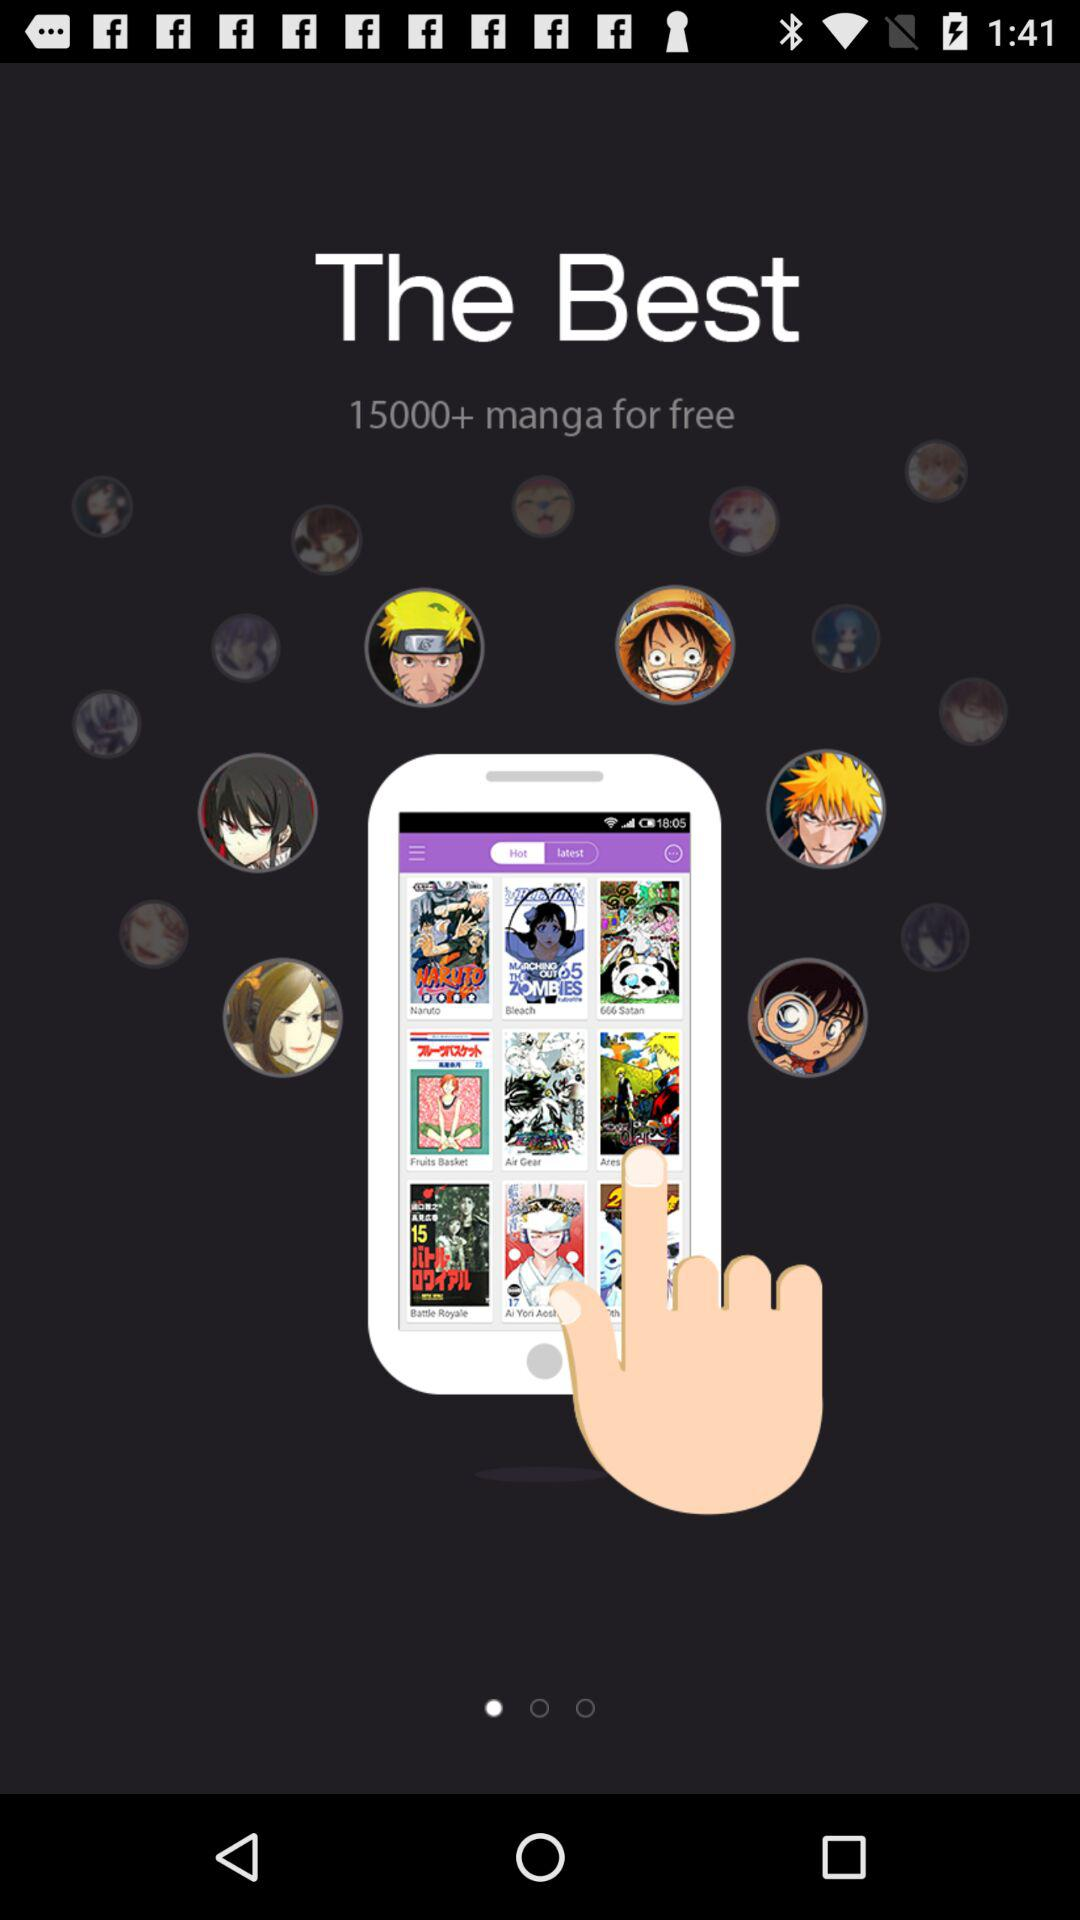What is the new version? The new version is 4.9.1. 